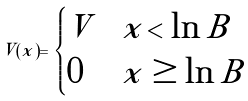Convert formula to latex. <formula><loc_0><loc_0><loc_500><loc_500>V ( x ) = \begin{cases} V & x < \ln B \\ 0 & x \geq \ln B \\ \end{cases}</formula> 